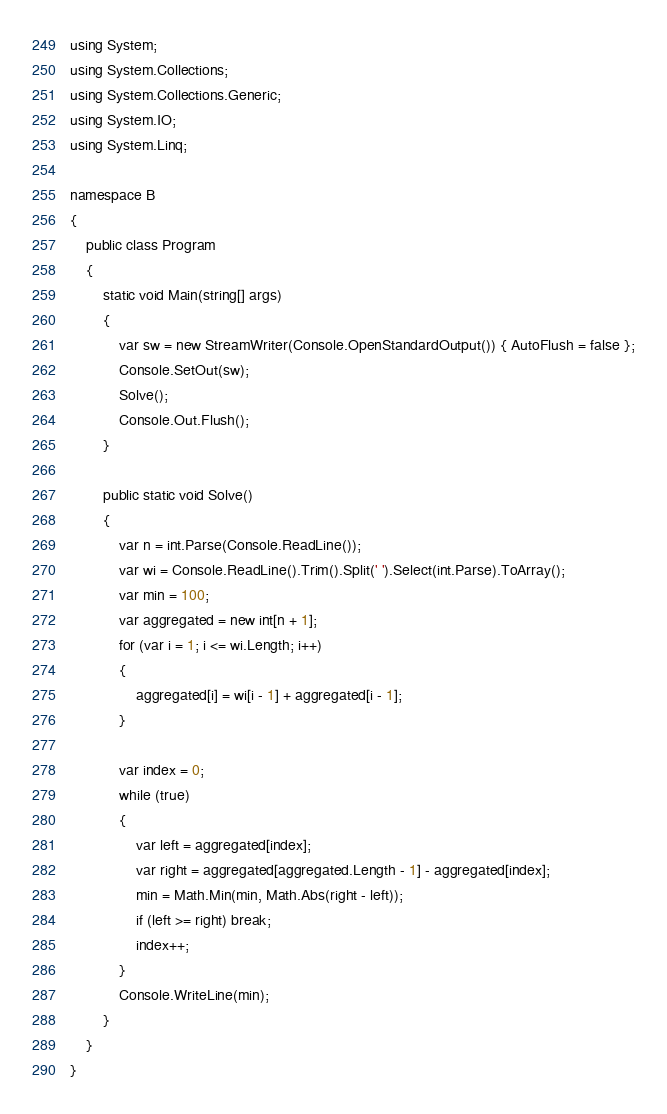<code> <loc_0><loc_0><loc_500><loc_500><_C#_>using System;
using System.Collections;
using System.Collections.Generic;
using System.IO;
using System.Linq;

namespace B
{
    public class Program
    {
        static void Main(string[] args)
        {
            var sw = new StreamWriter(Console.OpenStandardOutput()) { AutoFlush = false };
            Console.SetOut(sw);
            Solve();
            Console.Out.Flush();
        }

        public static void Solve()
        {
            var n = int.Parse(Console.ReadLine());
            var wi = Console.ReadLine().Trim().Split(' ').Select(int.Parse).ToArray();
            var min = 100;
            var aggregated = new int[n + 1];
            for (var i = 1; i <= wi.Length; i++)
            {
                aggregated[i] = wi[i - 1] + aggregated[i - 1];
            }

            var index = 0;
            while (true)
            {
                var left = aggregated[index];
                var right = aggregated[aggregated.Length - 1] - aggregated[index];
                min = Math.Min(min, Math.Abs(right - left));
                if (left >= right) break;
                index++;
            }
            Console.WriteLine(min);
        }
    }
}
</code> 